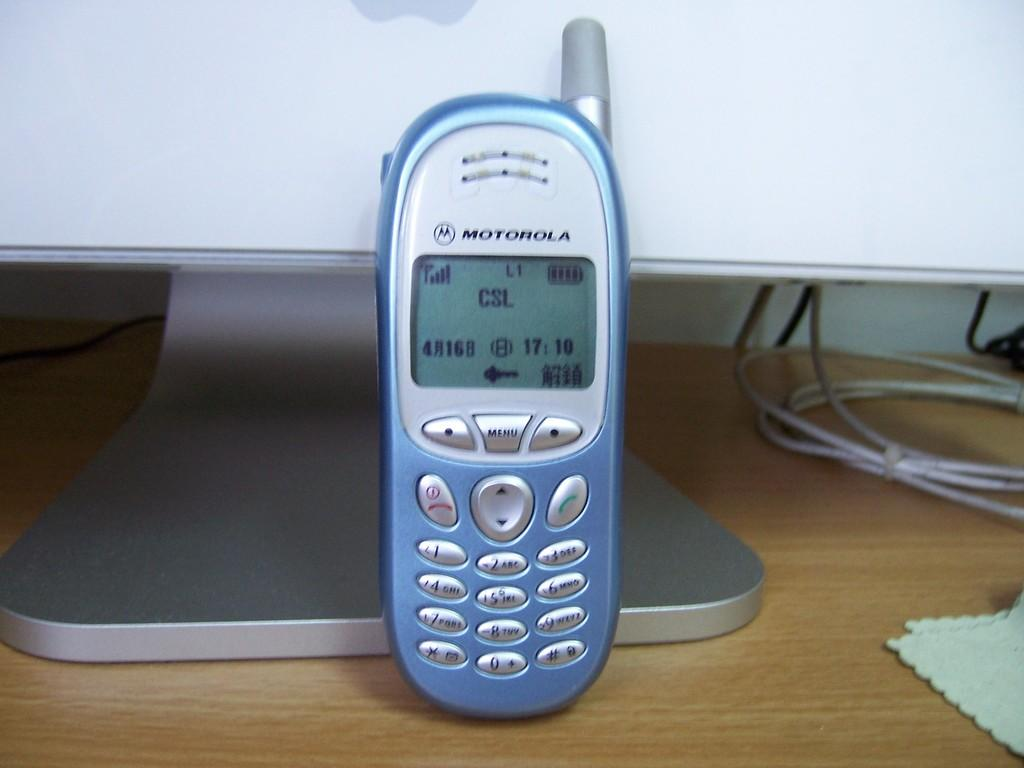<image>
Write a terse but informative summary of the picture. A motorola cell phone in powder blue on a desk. 